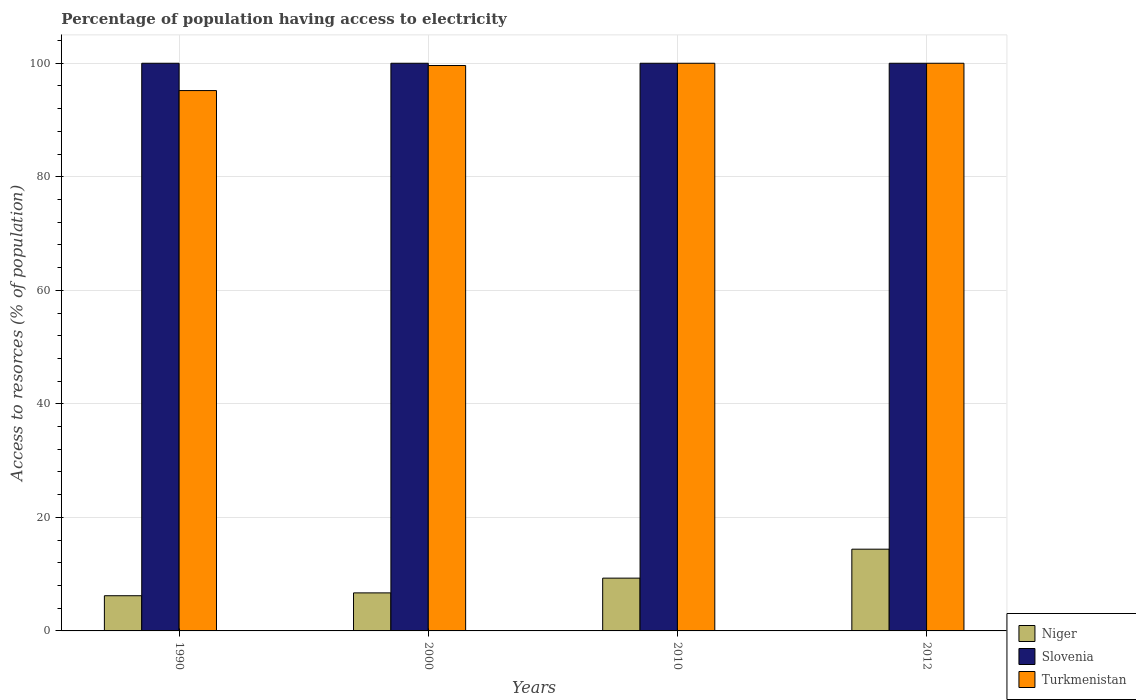How many different coloured bars are there?
Ensure brevity in your answer.  3. Are the number of bars per tick equal to the number of legend labels?
Your answer should be compact. Yes. Are the number of bars on each tick of the X-axis equal?
Offer a very short reply. Yes. How many bars are there on the 2nd tick from the right?
Provide a short and direct response. 3. In how many cases, is the number of bars for a given year not equal to the number of legend labels?
Offer a terse response. 0. What is the percentage of population having access to electricity in Niger in 1990?
Offer a terse response. 6.2. Across all years, what is the maximum percentage of population having access to electricity in Slovenia?
Your answer should be compact. 100. Across all years, what is the minimum percentage of population having access to electricity in Slovenia?
Your response must be concise. 100. What is the total percentage of population having access to electricity in Turkmenistan in the graph?
Offer a very short reply. 394.79. What is the difference between the percentage of population having access to electricity in Niger in 2000 and that in 2010?
Provide a succinct answer. -2.6. What is the difference between the percentage of population having access to electricity in Turkmenistan in 2000 and the percentage of population having access to electricity in Slovenia in 2012?
Provide a short and direct response. -0.4. What is the average percentage of population having access to electricity in Slovenia per year?
Keep it short and to the point. 100. In the year 2012, what is the difference between the percentage of population having access to electricity in Slovenia and percentage of population having access to electricity in Niger?
Keep it short and to the point. 85.6. What is the ratio of the percentage of population having access to electricity in Niger in 1990 to that in 2000?
Offer a terse response. 0.93. What is the difference between the highest and the lowest percentage of population having access to electricity in Niger?
Offer a very short reply. 8.2. Is the sum of the percentage of population having access to electricity in Niger in 2000 and 2010 greater than the maximum percentage of population having access to electricity in Turkmenistan across all years?
Provide a short and direct response. No. What does the 1st bar from the left in 2000 represents?
Make the answer very short. Niger. What does the 3rd bar from the right in 2012 represents?
Offer a terse response. Niger. Is it the case that in every year, the sum of the percentage of population having access to electricity in Slovenia and percentage of population having access to electricity in Niger is greater than the percentage of population having access to electricity in Turkmenistan?
Provide a short and direct response. Yes. Are all the bars in the graph horizontal?
Provide a short and direct response. No. What is the difference between two consecutive major ticks on the Y-axis?
Keep it short and to the point. 20. Does the graph contain grids?
Make the answer very short. Yes. Where does the legend appear in the graph?
Your response must be concise. Bottom right. How are the legend labels stacked?
Offer a terse response. Vertical. What is the title of the graph?
Provide a short and direct response. Percentage of population having access to electricity. Does "Montenegro" appear as one of the legend labels in the graph?
Provide a short and direct response. No. What is the label or title of the Y-axis?
Keep it short and to the point. Access to resorces (% of population). What is the Access to resorces (% of population) of Niger in 1990?
Give a very brief answer. 6.2. What is the Access to resorces (% of population) of Turkmenistan in 1990?
Make the answer very short. 95.19. What is the Access to resorces (% of population) of Slovenia in 2000?
Offer a very short reply. 100. What is the Access to resorces (% of population) in Turkmenistan in 2000?
Your response must be concise. 99.6. What is the Access to resorces (% of population) in Turkmenistan in 2010?
Provide a succinct answer. 100. Across all years, what is the maximum Access to resorces (% of population) in Niger?
Provide a succinct answer. 14.4. Across all years, what is the maximum Access to resorces (% of population) in Turkmenistan?
Keep it short and to the point. 100. Across all years, what is the minimum Access to resorces (% of population) of Niger?
Offer a very short reply. 6.2. Across all years, what is the minimum Access to resorces (% of population) in Slovenia?
Offer a terse response. 100. Across all years, what is the minimum Access to resorces (% of population) of Turkmenistan?
Offer a terse response. 95.19. What is the total Access to resorces (% of population) in Niger in the graph?
Your response must be concise. 36.6. What is the total Access to resorces (% of population) in Slovenia in the graph?
Your answer should be compact. 400. What is the total Access to resorces (% of population) in Turkmenistan in the graph?
Provide a short and direct response. 394.79. What is the difference between the Access to resorces (% of population) in Turkmenistan in 1990 and that in 2000?
Your response must be concise. -4.41. What is the difference between the Access to resorces (% of population) of Niger in 1990 and that in 2010?
Your answer should be very brief. -3.1. What is the difference between the Access to resorces (% of population) of Slovenia in 1990 and that in 2010?
Provide a succinct answer. 0. What is the difference between the Access to resorces (% of population) in Turkmenistan in 1990 and that in 2010?
Keep it short and to the point. -4.81. What is the difference between the Access to resorces (% of population) in Niger in 1990 and that in 2012?
Your answer should be very brief. -8.2. What is the difference between the Access to resorces (% of population) in Slovenia in 1990 and that in 2012?
Provide a succinct answer. 0. What is the difference between the Access to resorces (% of population) in Turkmenistan in 1990 and that in 2012?
Your response must be concise. -4.81. What is the difference between the Access to resorces (% of population) of Niger in 2000 and that in 2010?
Offer a terse response. -2.6. What is the difference between the Access to resorces (% of population) in Slovenia in 2000 and that in 2010?
Your answer should be compact. 0. What is the difference between the Access to resorces (% of population) in Niger in 2000 and that in 2012?
Provide a succinct answer. -7.7. What is the difference between the Access to resorces (% of population) in Slovenia in 2000 and that in 2012?
Your answer should be compact. 0. What is the difference between the Access to resorces (% of population) in Niger in 2010 and that in 2012?
Offer a terse response. -5.1. What is the difference between the Access to resorces (% of population) in Slovenia in 2010 and that in 2012?
Ensure brevity in your answer.  0. What is the difference between the Access to resorces (% of population) of Niger in 1990 and the Access to resorces (% of population) of Slovenia in 2000?
Your answer should be compact. -93.8. What is the difference between the Access to resorces (% of population) of Niger in 1990 and the Access to resorces (% of population) of Turkmenistan in 2000?
Provide a succinct answer. -93.4. What is the difference between the Access to resorces (% of population) in Niger in 1990 and the Access to resorces (% of population) in Slovenia in 2010?
Your answer should be very brief. -93.8. What is the difference between the Access to resorces (% of population) of Niger in 1990 and the Access to resorces (% of population) of Turkmenistan in 2010?
Your answer should be compact. -93.8. What is the difference between the Access to resorces (% of population) of Slovenia in 1990 and the Access to resorces (% of population) of Turkmenistan in 2010?
Offer a very short reply. 0. What is the difference between the Access to resorces (% of population) in Niger in 1990 and the Access to resorces (% of population) in Slovenia in 2012?
Make the answer very short. -93.8. What is the difference between the Access to resorces (% of population) in Niger in 1990 and the Access to resorces (% of population) in Turkmenistan in 2012?
Provide a succinct answer. -93.8. What is the difference between the Access to resorces (% of population) in Slovenia in 1990 and the Access to resorces (% of population) in Turkmenistan in 2012?
Offer a very short reply. 0. What is the difference between the Access to resorces (% of population) of Niger in 2000 and the Access to resorces (% of population) of Slovenia in 2010?
Offer a terse response. -93.3. What is the difference between the Access to resorces (% of population) in Niger in 2000 and the Access to resorces (% of population) in Turkmenistan in 2010?
Your response must be concise. -93.3. What is the difference between the Access to resorces (% of population) of Niger in 2000 and the Access to resorces (% of population) of Slovenia in 2012?
Give a very brief answer. -93.3. What is the difference between the Access to resorces (% of population) of Niger in 2000 and the Access to resorces (% of population) of Turkmenistan in 2012?
Offer a terse response. -93.3. What is the difference between the Access to resorces (% of population) of Niger in 2010 and the Access to resorces (% of population) of Slovenia in 2012?
Give a very brief answer. -90.7. What is the difference between the Access to resorces (% of population) of Niger in 2010 and the Access to resorces (% of population) of Turkmenistan in 2012?
Ensure brevity in your answer.  -90.7. What is the difference between the Access to resorces (% of population) of Slovenia in 2010 and the Access to resorces (% of population) of Turkmenistan in 2012?
Your answer should be compact. 0. What is the average Access to resorces (% of population) in Niger per year?
Your answer should be very brief. 9.15. What is the average Access to resorces (% of population) in Slovenia per year?
Your response must be concise. 100. What is the average Access to resorces (% of population) of Turkmenistan per year?
Your answer should be very brief. 98.7. In the year 1990, what is the difference between the Access to resorces (% of population) in Niger and Access to resorces (% of population) in Slovenia?
Your answer should be compact. -93.8. In the year 1990, what is the difference between the Access to resorces (% of population) of Niger and Access to resorces (% of population) of Turkmenistan?
Your response must be concise. -88.99. In the year 1990, what is the difference between the Access to resorces (% of population) in Slovenia and Access to resorces (% of population) in Turkmenistan?
Offer a terse response. 4.81. In the year 2000, what is the difference between the Access to resorces (% of population) in Niger and Access to resorces (% of population) in Slovenia?
Your answer should be compact. -93.3. In the year 2000, what is the difference between the Access to resorces (% of population) in Niger and Access to resorces (% of population) in Turkmenistan?
Provide a succinct answer. -92.9. In the year 2000, what is the difference between the Access to resorces (% of population) of Slovenia and Access to resorces (% of population) of Turkmenistan?
Offer a terse response. 0.4. In the year 2010, what is the difference between the Access to resorces (% of population) of Niger and Access to resorces (% of population) of Slovenia?
Provide a succinct answer. -90.7. In the year 2010, what is the difference between the Access to resorces (% of population) of Niger and Access to resorces (% of population) of Turkmenistan?
Your response must be concise. -90.7. In the year 2010, what is the difference between the Access to resorces (% of population) of Slovenia and Access to resorces (% of population) of Turkmenistan?
Keep it short and to the point. 0. In the year 2012, what is the difference between the Access to resorces (% of population) of Niger and Access to resorces (% of population) of Slovenia?
Provide a succinct answer. -85.6. In the year 2012, what is the difference between the Access to resorces (% of population) of Niger and Access to resorces (% of population) of Turkmenistan?
Provide a succinct answer. -85.6. In the year 2012, what is the difference between the Access to resorces (% of population) in Slovenia and Access to resorces (% of population) in Turkmenistan?
Offer a very short reply. 0. What is the ratio of the Access to resorces (% of population) in Niger in 1990 to that in 2000?
Keep it short and to the point. 0.93. What is the ratio of the Access to resorces (% of population) of Slovenia in 1990 to that in 2000?
Give a very brief answer. 1. What is the ratio of the Access to resorces (% of population) in Turkmenistan in 1990 to that in 2000?
Give a very brief answer. 0.96. What is the ratio of the Access to resorces (% of population) of Turkmenistan in 1990 to that in 2010?
Offer a very short reply. 0.95. What is the ratio of the Access to resorces (% of population) of Niger in 1990 to that in 2012?
Keep it short and to the point. 0.43. What is the ratio of the Access to resorces (% of population) of Slovenia in 1990 to that in 2012?
Offer a very short reply. 1. What is the ratio of the Access to resorces (% of population) in Turkmenistan in 1990 to that in 2012?
Keep it short and to the point. 0.95. What is the ratio of the Access to resorces (% of population) in Niger in 2000 to that in 2010?
Offer a very short reply. 0.72. What is the ratio of the Access to resorces (% of population) of Slovenia in 2000 to that in 2010?
Offer a very short reply. 1. What is the ratio of the Access to resorces (% of population) of Niger in 2000 to that in 2012?
Provide a short and direct response. 0.47. What is the ratio of the Access to resorces (% of population) of Slovenia in 2000 to that in 2012?
Your answer should be compact. 1. What is the ratio of the Access to resorces (% of population) in Turkmenistan in 2000 to that in 2012?
Your response must be concise. 1. What is the ratio of the Access to resorces (% of population) of Niger in 2010 to that in 2012?
Provide a short and direct response. 0.65. What is the ratio of the Access to resorces (% of population) of Turkmenistan in 2010 to that in 2012?
Make the answer very short. 1. What is the difference between the highest and the lowest Access to resorces (% of population) of Turkmenistan?
Your answer should be very brief. 4.81. 